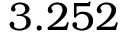<formula> <loc_0><loc_0><loc_500><loc_500>3 . 2 5 2</formula> 